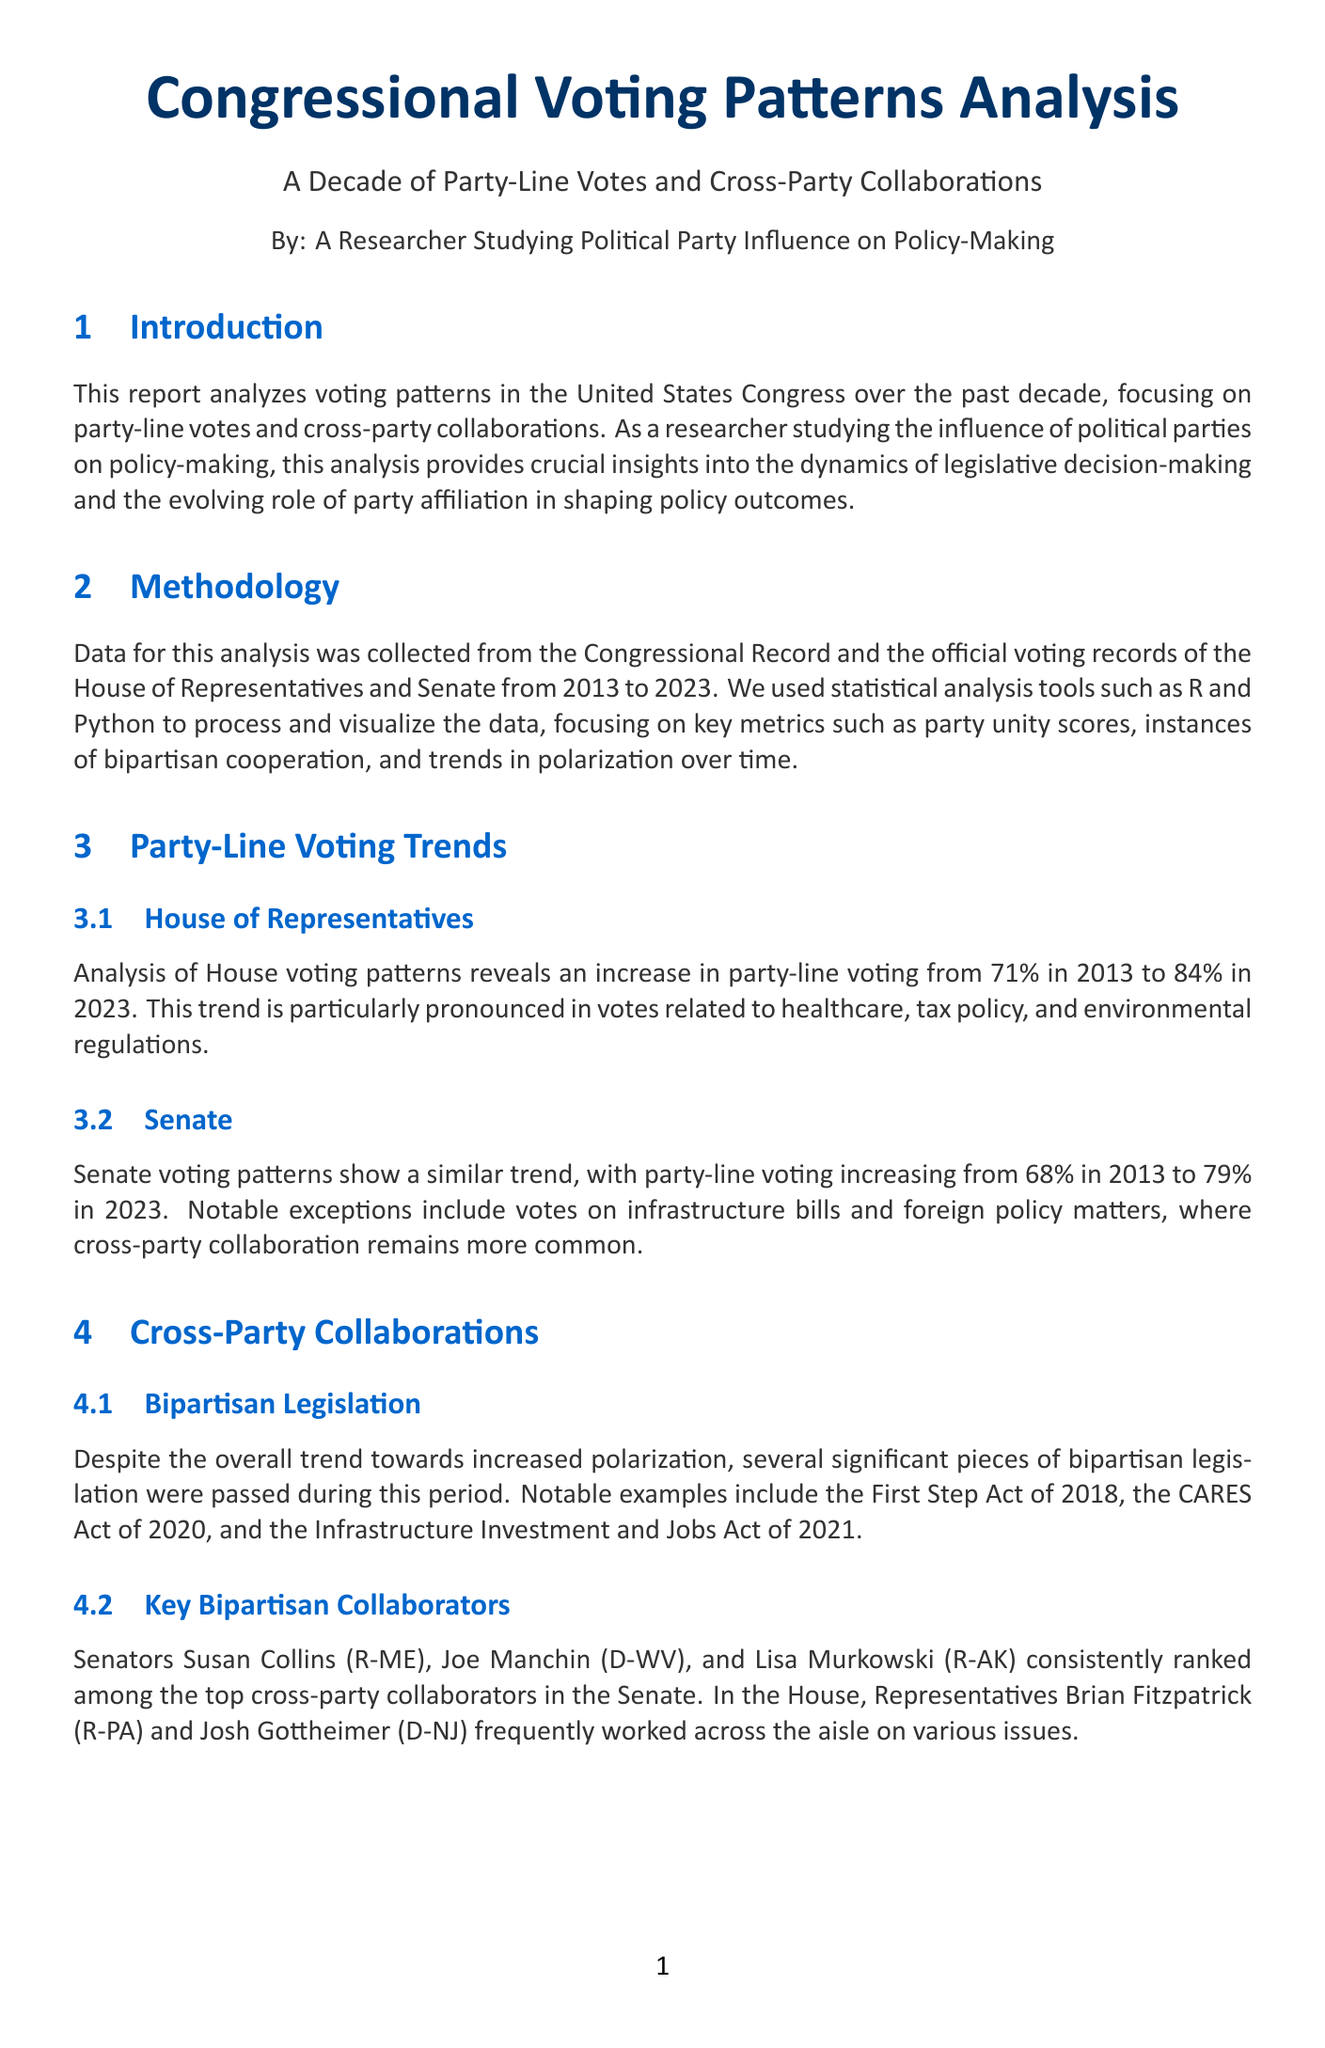What was the percentage of party-line voting in the House in 2013? The percentage of party-line voting in the House in 2013 was 71%.
Answer: 71% Who were the top cross-party collaborators in the Senate? The document lists Senators Susan Collins, Joe Manchin, and Lisa Murkowski as the top cross-party collaborators in the Senate.
Answer: Susan Collins, Joe Manchin, Lisa Murkowski What significant bipartisan legislation was passed in 2020? The document mentions the CARES Act as a significant piece of bipartisan legislation passed in 2020.
Answer: CARES Act What trend was observed in party-line voting leading up to elections? The report indicates that party-line voting tends to increase in the months leading up to midterm and presidential elections.
Answer: Increase Which policy areas consistently show higher levels of party-line voting? The document states that climate change legislation, gun control measures, and immigration reform show higher levels of party-line voting.
Answer: Climate change, gun control, immigration What is the increasing trend of party-line voting an indication of? The trend suggests that party affiliation is becoming an increasingly important factor in shaping legislative outcomes.
Answer: Party affiliation importance What years does the analysis cover? The analysis covers the years from 2013 to 2023.
Answer: 2013 to 2023 What notable exceptions to party-line voting trends are mentioned? Votes on infrastructure bills and foreign policy matters are mentioned as notable exceptions to party-line voting trends.
Answer: Infrastructure bills, foreign policy 